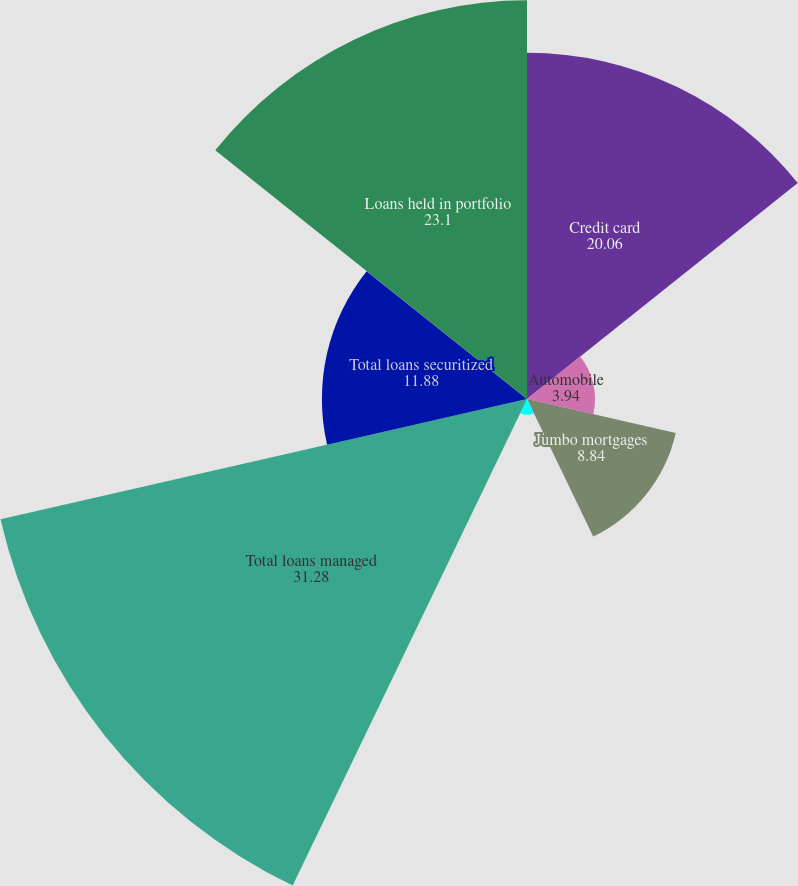<chart> <loc_0><loc_0><loc_500><loc_500><pie_chart><fcel>Credit card<fcel>Automobile<fcel>Jumbo mortgages<fcel>SBA<fcel>Total loans managed<fcel>Total loans securitized<fcel>Loans held in portfolio<nl><fcel>20.06%<fcel>3.94%<fcel>8.84%<fcel>0.91%<fcel>31.28%<fcel>11.88%<fcel>23.1%<nl></chart> 